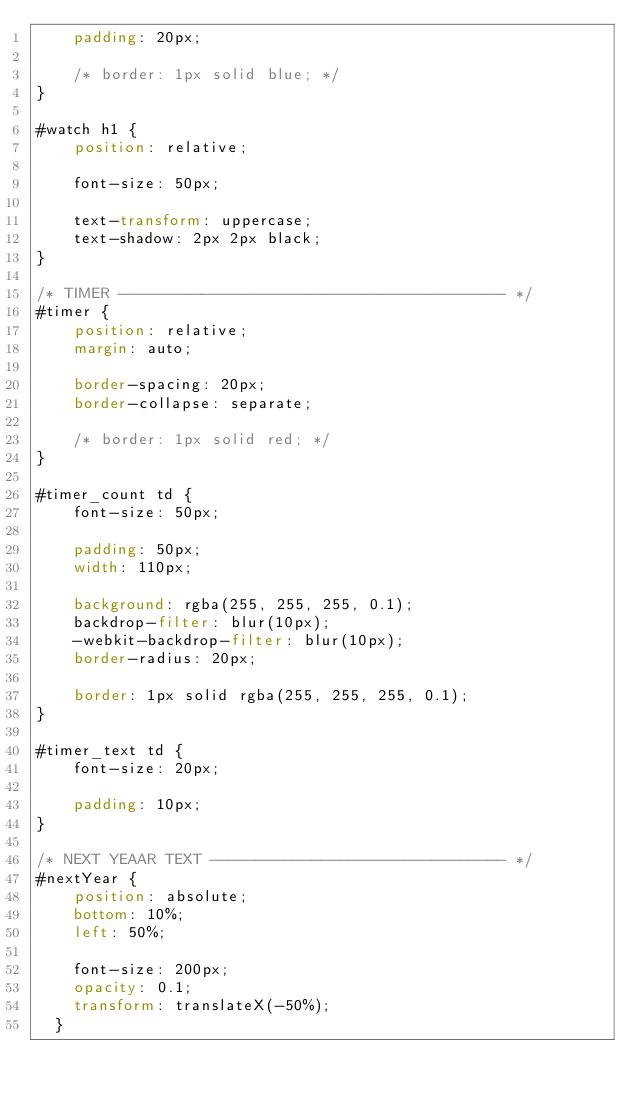<code> <loc_0><loc_0><loc_500><loc_500><_CSS_>    padding: 20px;

    /* border: 1px solid blue; */
}

#watch h1 {
    position: relative;

    font-size: 50px;

    text-transform: uppercase;
    text-shadow: 2px 2px black;
}

/* TIMER ------------------------------------------ */
#timer {
    position: relative;
    margin: auto;

    border-spacing: 20px;
    border-collapse: separate;

    /* border: 1px solid red; */
}

#timer_count td {
    font-size: 50px;

    padding: 50px;
    width: 110px;

    background: rgba(255, 255, 255, 0.1);
    backdrop-filter: blur(10px);
    -webkit-backdrop-filter: blur(10px);
    border-radius: 20px;
    
    border: 1px solid rgba(255, 255, 255, 0.1); 
}

#timer_text td {
    font-size: 20px;

    padding: 10px;
}

/* NEXT YEAAR TEXT -------------------------------- */
#nextYear {
    position: absolute;
    bottom: 10%;
    left: 50%;

    font-size: 200px;
    opacity: 0.1;
    transform: translateX(-50%);
  }</code> 